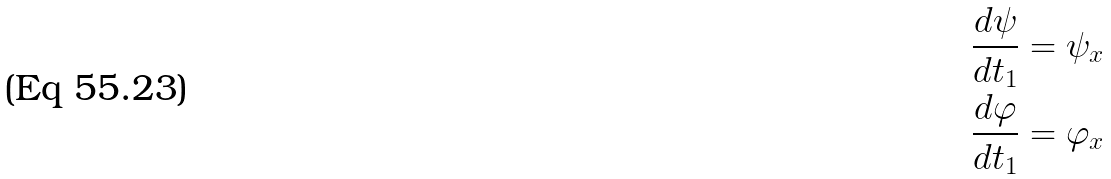<formula> <loc_0><loc_0><loc_500><loc_500>\frac { d \psi } { d t _ { 1 } } & = \psi _ { x } \\ \frac { d \varphi } { d t _ { 1 } } & = \varphi _ { x }</formula> 